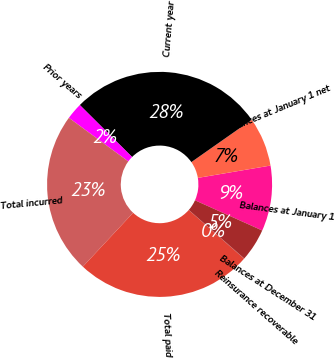Convert chart. <chart><loc_0><loc_0><loc_500><loc_500><pie_chart><fcel>Balances at January 1<fcel>Balances at January 1 net<fcel>Current year<fcel>Prior years<fcel>Total incurred<fcel>Total paid<fcel>Reinsurance recoverable<fcel>Balances at December 31<nl><fcel>9.4%<fcel>7.06%<fcel>27.81%<fcel>2.38%<fcel>23.13%<fcel>25.47%<fcel>0.04%<fcel>4.72%<nl></chart> 